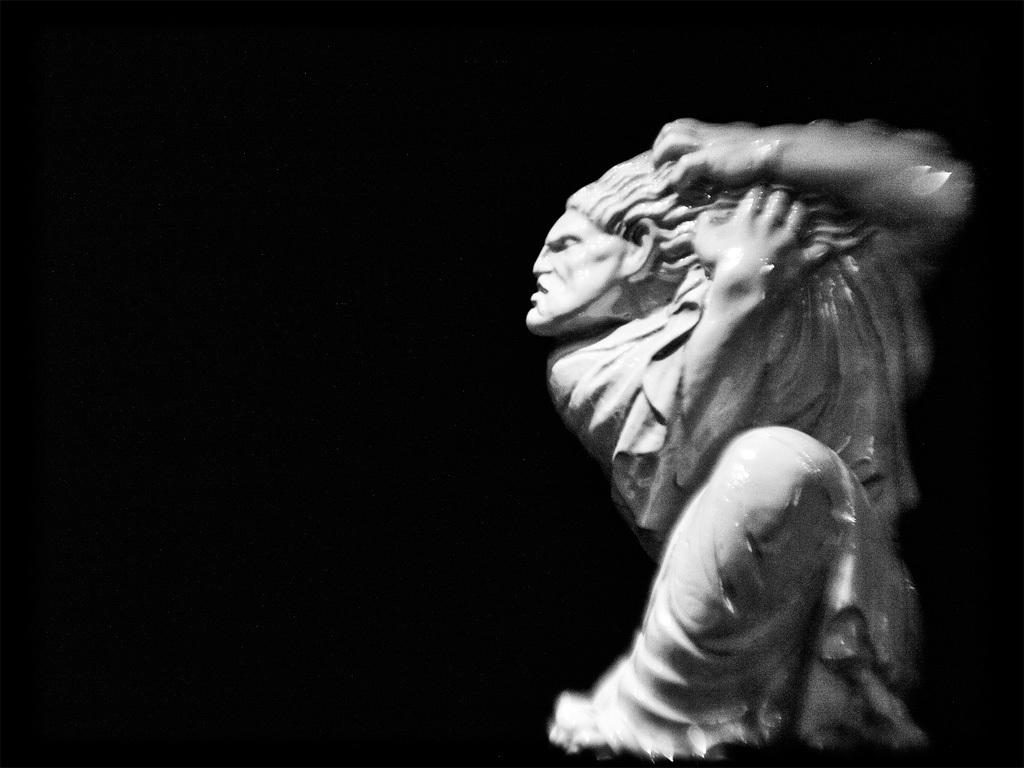What is the main subject of the image? There is a statue in the image. What is the color of the statue? The statue is white in color. What can be observed about the background of the image? The background of the image is dark. Can you see a tiger playing a record with its toothbrush in the image? No, there is no tiger, record, or toothbrush present in the image. 